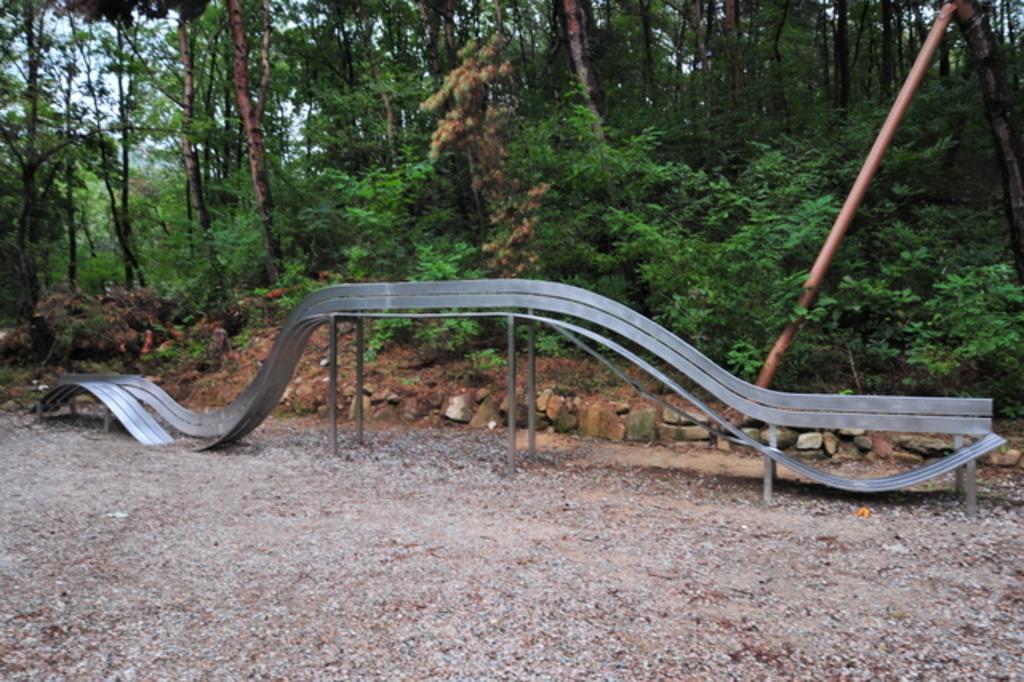How would you summarize this image in a sentence or two? In the center of the image we can see a metal ramp on the ground. We can also see some stones, a pole, a group of trees and the sky. 